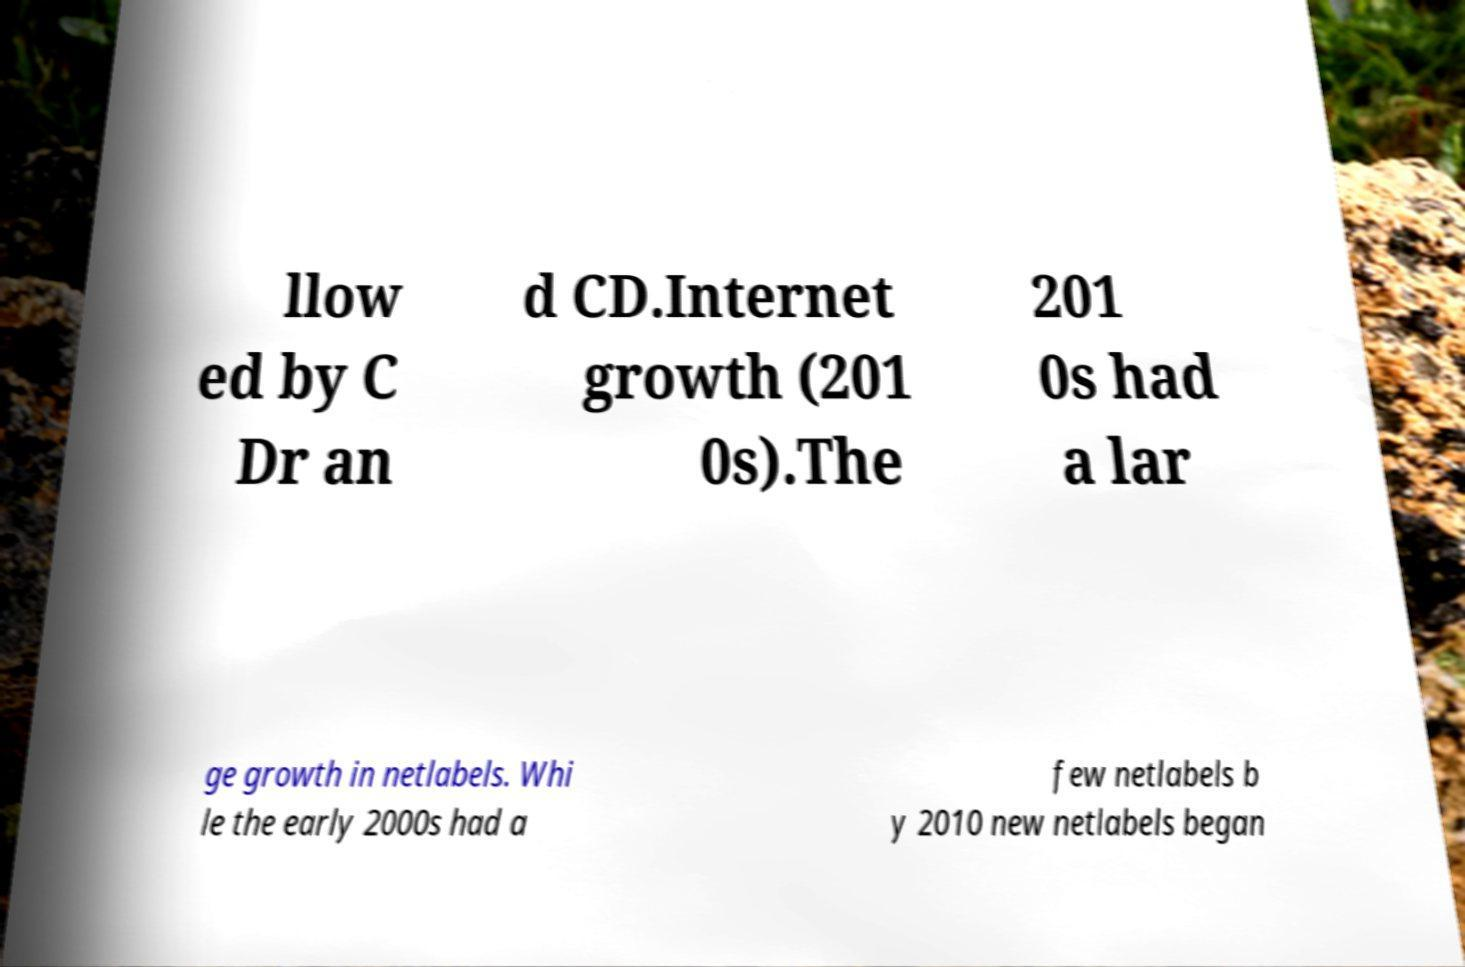Could you extract and type out the text from this image? llow ed by C Dr an d CD.Internet growth (201 0s).The 201 0s had a lar ge growth in netlabels. Whi le the early 2000s had a few netlabels b y 2010 new netlabels began 